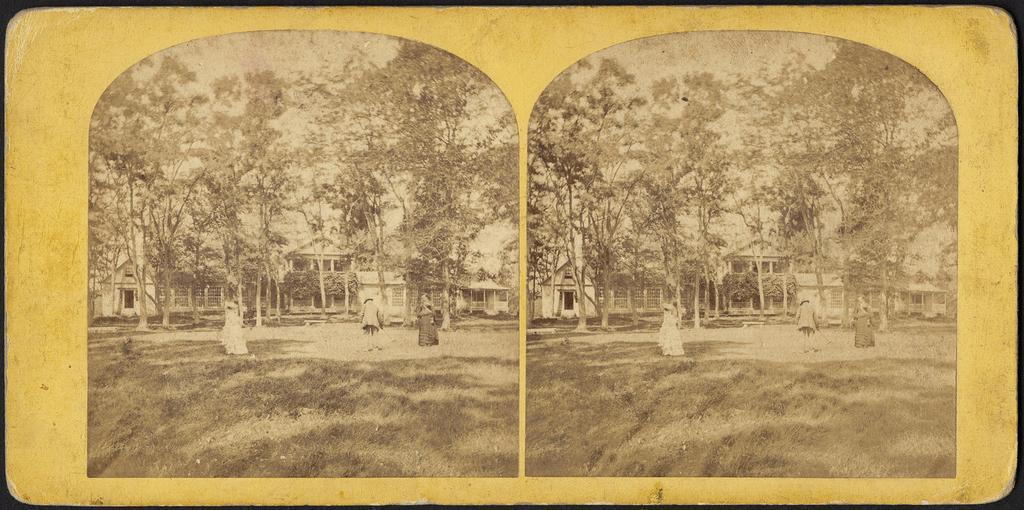Describe this image in one or two sentences. This is an editor and collage picture. In this image there is a building and there are trees and there are group of people standing. At the top there is sky. At the bottom there is grass. 